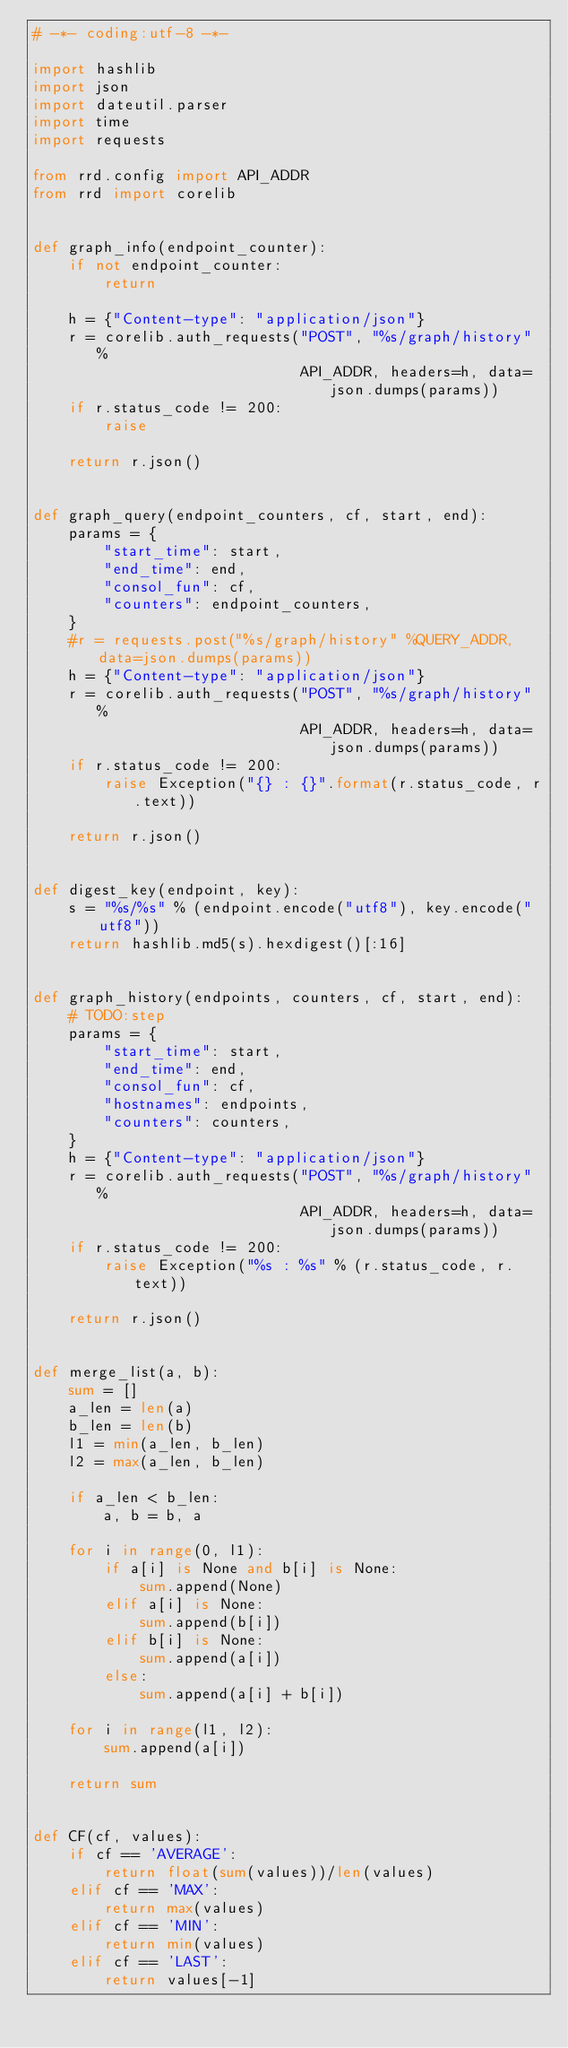Convert code to text. <code><loc_0><loc_0><loc_500><loc_500><_Python_># -*- coding:utf-8 -*-

import hashlib
import json
import dateutil.parser
import time
import requests

from rrd.config import API_ADDR
from rrd import corelib


def graph_info(endpoint_counter):
    if not endpoint_counter:
        return

    h = {"Content-type": "application/json"}
    r = corelib.auth_requests("POST", "%s/graph/history" %
                              API_ADDR, headers=h, data=json.dumps(params))
    if r.status_code != 200:
        raise

    return r.json()


def graph_query(endpoint_counters, cf, start, end):
    params = {
        "start_time": start,
        "end_time": end,
        "consol_fun": cf,
        "counters": endpoint_counters,
    }
    #r = requests.post("%s/graph/history" %QUERY_ADDR, data=json.dumps(params))
    h = {"Content-type": "application/json"}
    r = corelib.auth_requests("POST", "%s/graph/history" %
                              API_ADDR, headers=h, data=json.dumps(params))
    if r.status_code != 200:
        raise Exception("{} : {}".format(r.status_code, r.text))

    return r.json()


def digest_key(endpoint, key):
    s = "%s/%s" % (endpoint.encode("utf8"), key.encode("utf8"))
    return hashlib.md5(s).hexdigest()[:16]


def graph_history(endpoints, counters, cf, start, end):
    # TODO:step
    params = {
        "start_time": start,
        "end_time": end,
        "consol_fun": cf,
        "hostnames": endpoints,
        "counters": counters,
    }
    h = {"Content-type": "application/json"}
    r = corelib.auth_requests("POST", "%s/graph/history" %
                              API_ADDR, headers=h, data=json.dumps(params))
    if r.status_code != 200:
        raise Exception("%s : %s" % (r.status_code, r.text))

    return r.json()


def merge_list(a, b):
    sum = []
    a_len = len(a)
    b_len = len(b)
    l1 = min(a_len, b_len)
    l2 = max(a_len, b_len)

    if a_len < b_len:
        a, b = b, a

    for i in range(0, l1):
        if a[i] is None and b[i] is None:
            sum.append(None)
        elif a[i] is None:
            sum.append(b[i])
        elif b[i] is None:
            sum.append(a[i])
        else:
            sum.append(a[i] + b[i])

    for i in range(l1, l2):
        sum.append(a[i])

    return sum


def CF(cf, values):
    if cf == 'AVERAGE':
        return float(sum(values))/len(values)
    elif cf == 'MAX':
        return max(values)
    elif cf == 'MIN':
        return min(values)
    elif cf == 'LAST':
        return values[-1]
</code> 